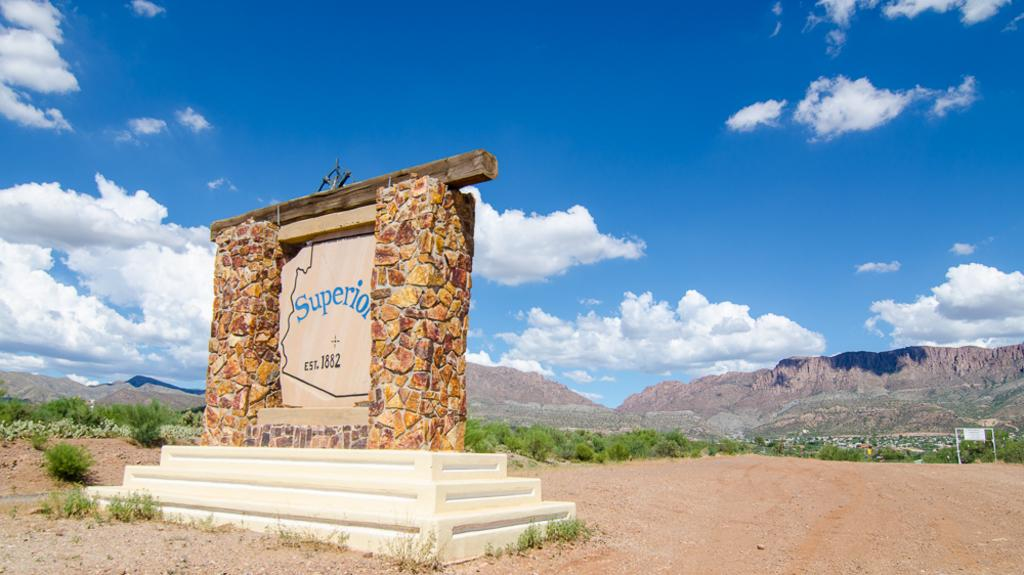What is the main subject in the foreground of the image? There is a memorial in the foreground of the image. What type of vegetation is present in the foreground of the image? Grass, plants, and trees are visible in the foreground of the image. What materials are used in the construction of the memorial? Metal rods are visible in the foreground of the image. What can be seen in the background of the image? There are houses, mountains, and the sky visible in the background of the image. Can you describe the time of day when the image was taken? The image was likely taken during the day, as the sky is visible. What type of suit or skirt is worn by the memorial in the image? The memorial is an inanimate object and does not wear clothing, so there is no suit or skirt present in the image. 